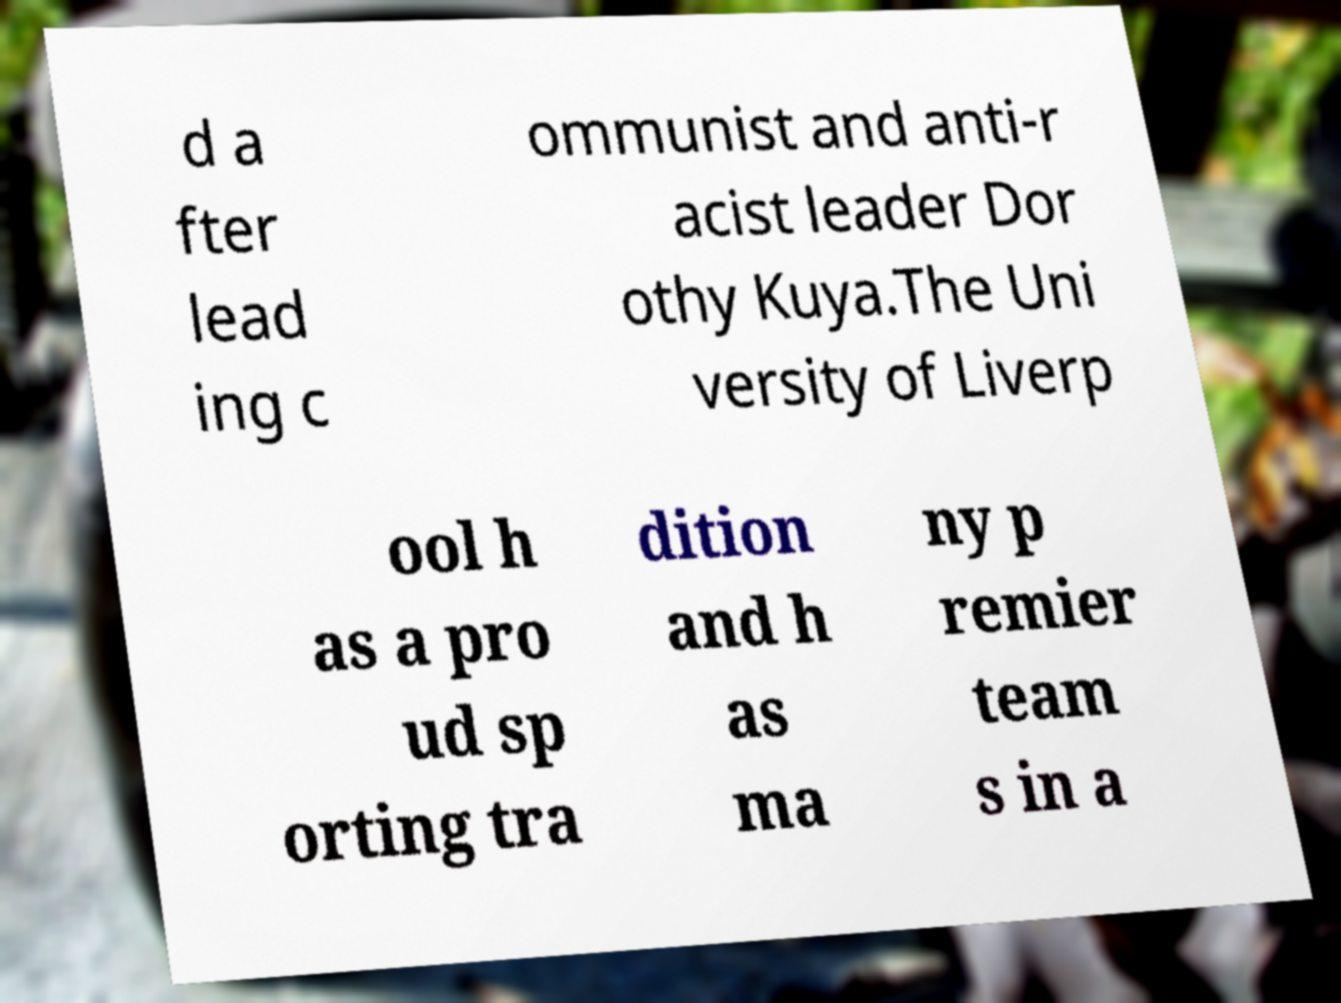Could you extract and type out the text from this image? d a fter lead ing c ommunist and anti-r acist leader Dor othy Kuya.The Uni versity of Liverp ool h as a pro ud sp orting tra dition and h as ma ny p remier team s in a 